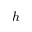<formula> <loc_0><loc_0><loc_500><loc_500>h</formula> 